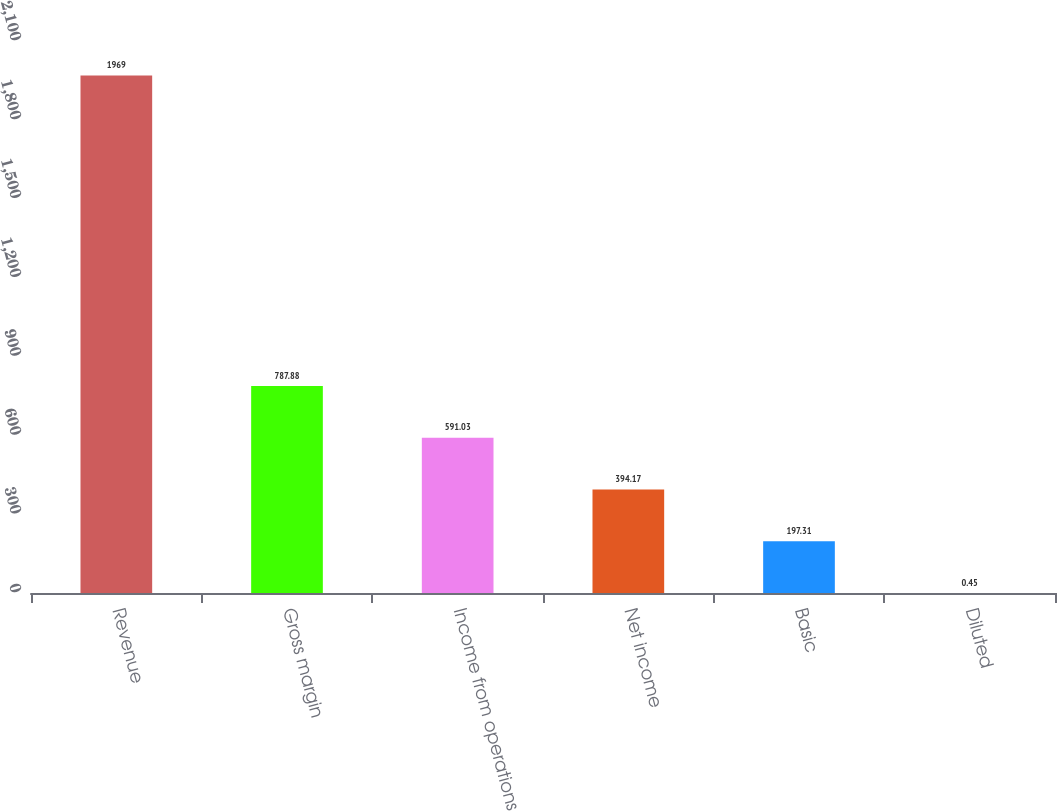<chart> <loc_0><loc_0><loc_500><loc_500><bar_chart><fcel>Revenue<fcel>Gross margin<fcel>Income from operations<fcel>Net income<fcel>Basic<fcel>Diluted<nl><fcel>1969<fcel>787.88<fcel>591.03<fcel>394.17<fcel>197.31<fcel>0.45<nl></chart> 